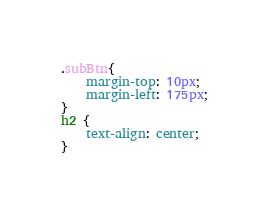Convert code to text. <code><loc_0><loc_0><loc_500><loc_500><_CSS_>.subBtn{
	margin-top: 10px;
	margin-left: 175px;
}
h2 {
	text-align: center;
}</code> 